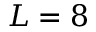<formula> <loc_0><loc_0><loc_500><loc_500>L = 8</formula> 